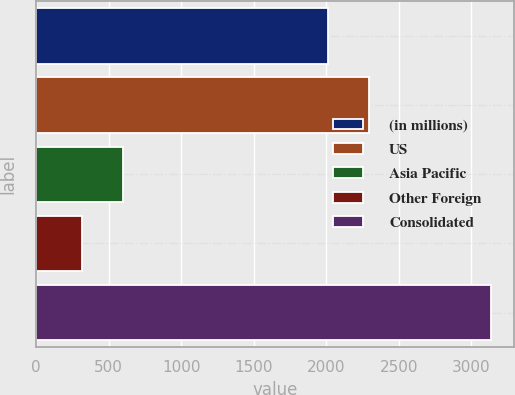Convert chart to OTSL. <chart><loc_0><loc_0><loc_500><loc_500><bar_chart><fcel>(in millions)<fcel>US<fcel>Asia Pacific<fcel>Other Foreign<fcel>Consolidated<nl><fcel>2015<fcel>2296.5<fcel>602<fcel>320<fcel>3135<nl></chart> 